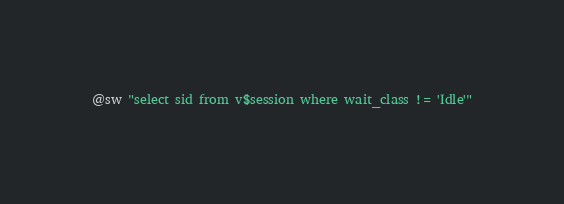Convert code to text. <code><loc_0><loc_0><loc_500><loc_500><_SQL_>@sw "select sid from v$session where wait_class != 'Idle'"
</code> 